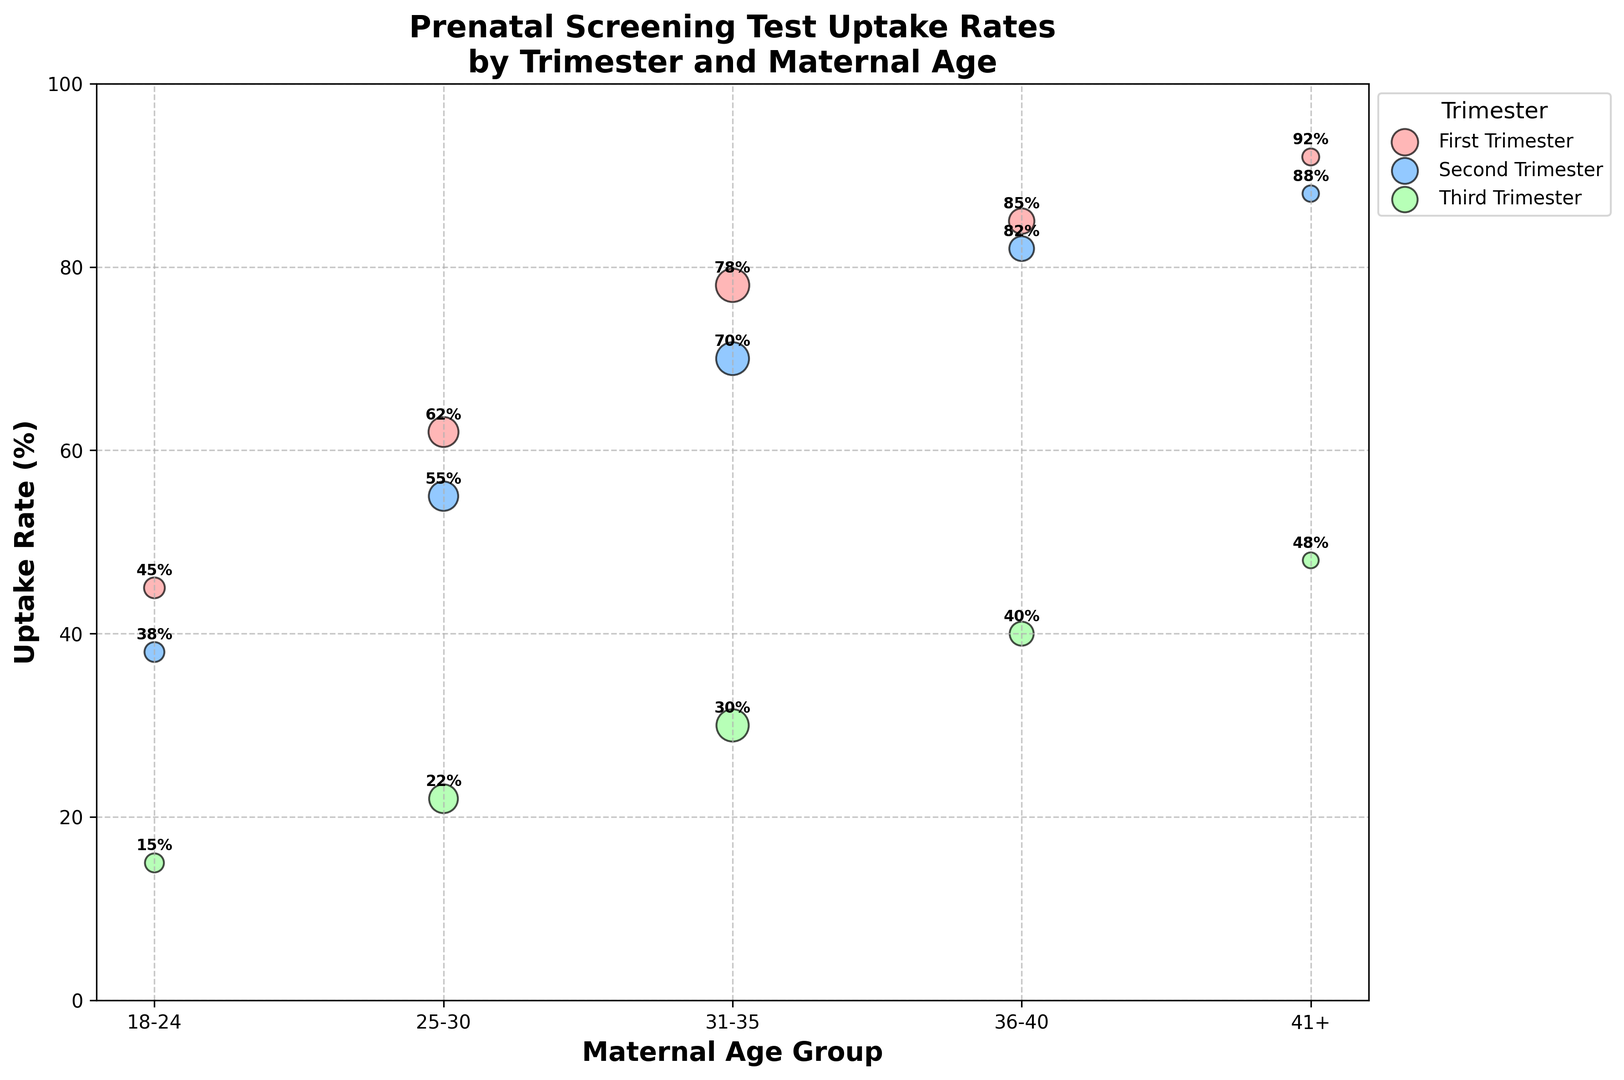Which trimester shows the highest uptake rate for the 41+ age group? The highest uptake rate in the 41+ age group is observed by looking at the data points for each trimester and selecting the one with the highest value. According to the figure, the 41+ group in the first trimester has the highest uptake rate (92%).
Answer: First What is the difference in uptake rates between the first and third trimesters for the 25-30 maternal age group? To find the difference, subtract the uptake rate of the third trimester from the uptake rate of the first trimester for the 25-30 age group. The uptake rates are 62% (first trimester) and 22% (third trimester), respectively. So, 62% - 22% = 40%.
Answer: 40% Which maternal age group shows the largest range in uptake rates across all trimesters? The range is calculated as the difference between the maximum and minimum uptake rates for each age group across all trimesters. By inspecting the data, we observe the uptake rates for each age group and calculate their ranges. The 18-24 age group has rates from 45% to 15%, yielding a range of 30%, which is the largest range compared to other age groups.
Answer: 18-24 How do the uptake rates for the 36-40 age group vary across the trimesters? By examining the bubble chart for the 36-40 age group across the trimesters, we identify their respective uptake rates: 85% (first trimester), 82% (second trimester), and 40% (third trimester). Therefore, they follow a decreasing pattern: 85%, 82%, and 40%.
Answer: 85%, 82%, 40% Which trimester has the most consistent uptake rates across different maternal age groups? Consistency is evaluated by comparing the spread of uptake rates within each trimester across all age groups. The second trimester has uptake rates ranging from 38% to 88%, showing less variation compared to the first (45% to 92%) and third trimesters (15% to 48%), indicating it is the most consistent.
Answer: Second What is the smallest sample size for any data point in the figure? To find the smallest sample size, observe the labels attached to the bubbles representing each data point. The sample sizes are given, and the smallest listed is 700 for the 41+ age group in the third trimester.
Answer: 700 Is there a pattern in how uptake rates progress across trimesters for the 31-35 age group? By checking the uptake rates for the 31-35 age group across all trimesters, we see the progression is from 78% (first trimester) to 70% (second trimester) to 30% (third trimester). This indicates a decreasing pattern in uptake rates across trimesters.
Answer: Decreasing Which trimester has the highest average uptake rate across all maternal age groups? To find the average uptake rate for each trimester, sum the uptake rates for all age groups within that trimester and divide by the number of age groups (5). For the first trimester: (45 + 62 + 78 + 85 + 92) / 5 = 72.4. For the second trimester: (38 + 55 + 70 + 82 + 88) / 5 = 66.6. For the third trimester: (15 + 22 + 30 + 40 + 48) / 5 = 31. The first trimester has the highest average at 72.4%.
Answer: First 